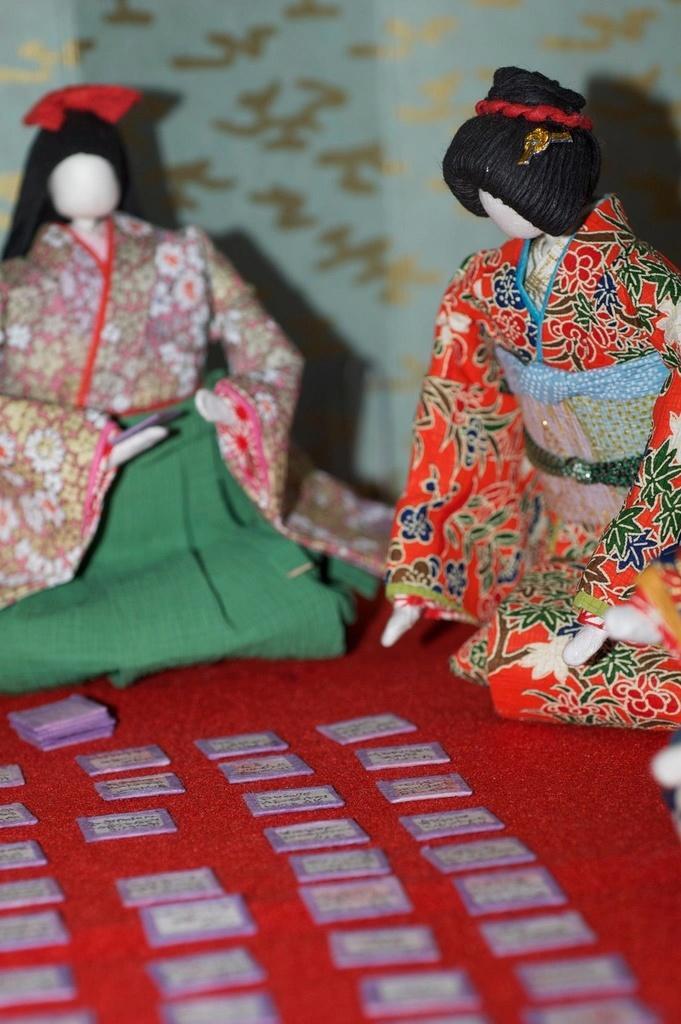Can you describe this image briefly? In this picture we can see couple Japanese paper crafts, in front of the crafts we can find few cards on the red color carpet. 